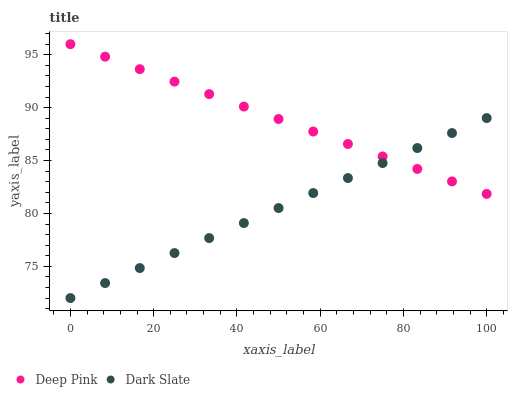Does Dark Slate have the minimum area under the curve?
Answer yes or no. Yes. Does Deep Pink have the maximum area under the curve?
Answer yes or no. Yes. Does Deep Pink have the minimum area under the curve?
Answer yes or no. No. Is Dark Slate the smoothest?
Answer yes or no. Yes. Is Deep Pink the roughest?
Answer yes or no. Yes. Is Deep Pink the smoothest?
Answer yes or no. No. Does Dark Slate have the lowest value?
Answer yes or no. Yes. Does Deep Pink have the lowest value?
Answer yes or no. No. Does Deep Pink have the highest value?
Answer yes or no. Yes. Does Dark Slate intersect Deep Pink?
Answer yes or no. Yes. Is Dark Slate less than Deep Pink?
Answer yes or no. No. Is Dark Slate greater than Deep Pink?
Answer yes or no. No. 